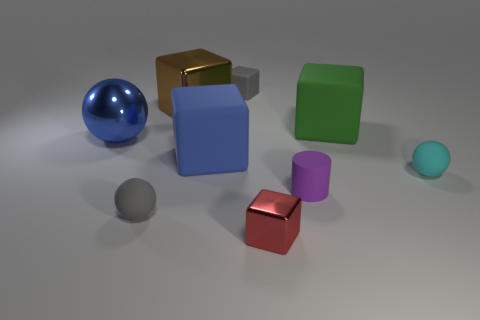There is a brown cube that is the same size as the green cube; what is its material? The brown cube, while visually similar in size to the green cube, has a characteristic sheen and reflection that suggests it is made of a polished metal, possibly bronze or copper. 